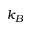Convert formula to latex. <formula><loc_0><loc_0><loc_500><loc_500>k _ { B }</formula> 